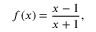Convert formula to latex. <formula><loc_0><loc_0><loc_500><loc_500>f ( x ) = { \frac { x - 1 } { x + 1 } } ,</formula> 